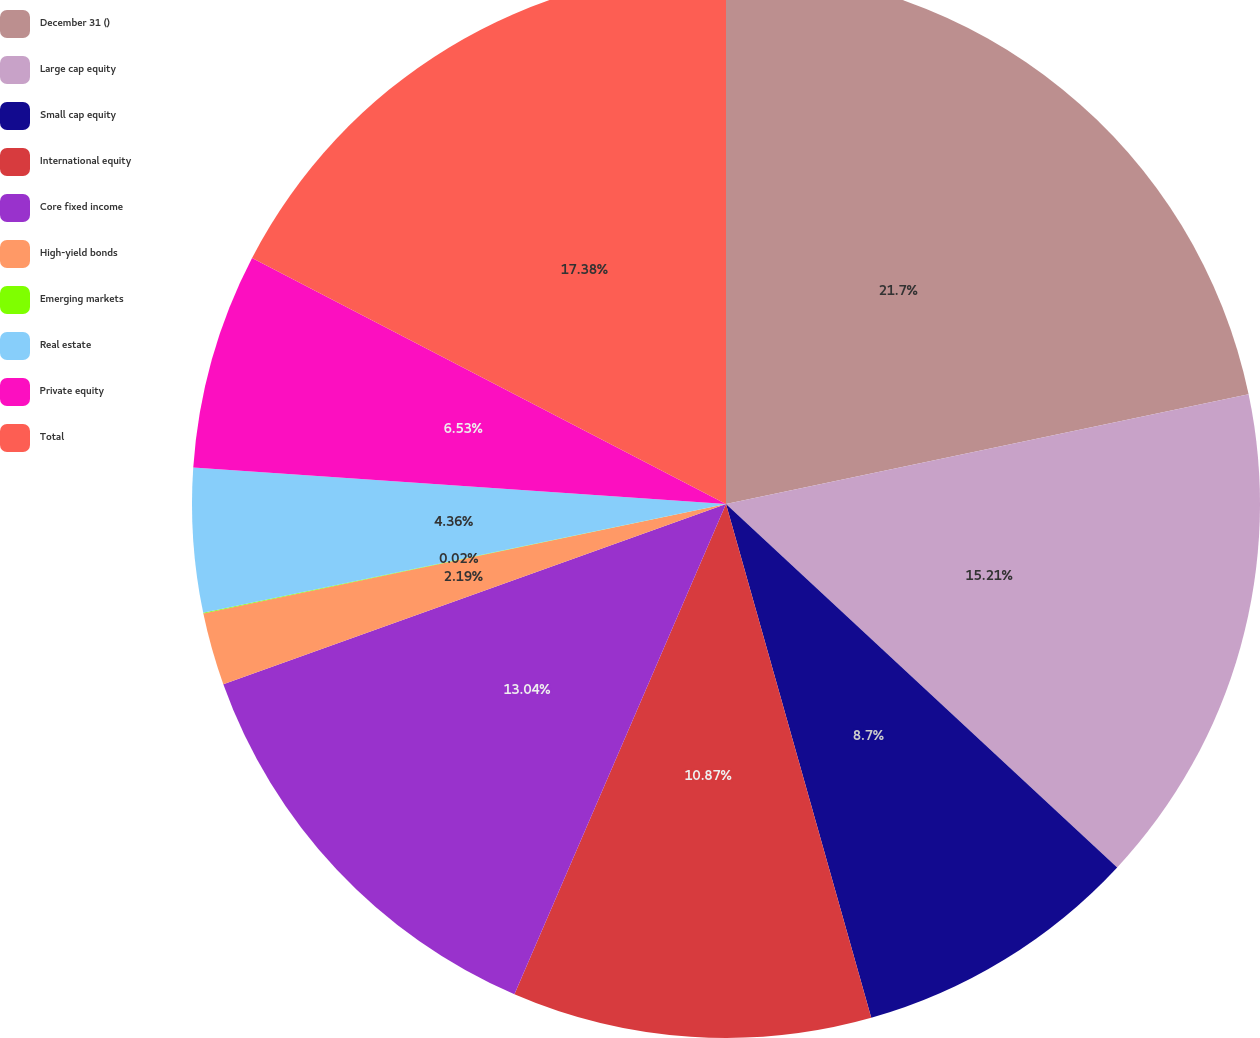<chart> <loc_0><loc_0><loc_500><loc_500><pie_chart><fcel>December 31 ()<fcel>Large cap equity<fcel>Small cap equity<fcel>International equity<fcel>Core fixed income<fcel>High-yield bonds<fcel>Emerging markets<fcel>Real estate<fcel>Private equity<fcel>Total<nl><fcel>21.71%<fcel>15.21%<fcel>8.7%<fcel>10.87%<fcel>13.04%<fcel>2.19%<fcel>0.02%<fcel>4.36%<fcel>6.53%<fcel>17.38%<nl></chart> 